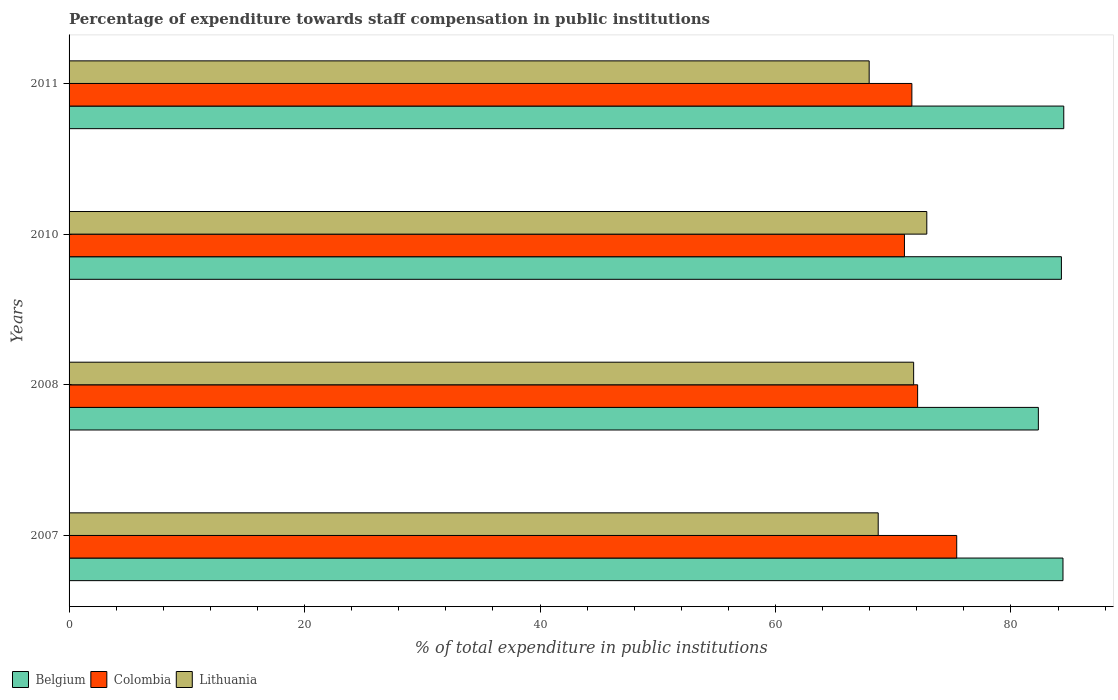How many different coloured bars are there?
Offer a very short reply. 3. Are the number of bars per tick equal to the number of legend labels?
Your answer should be very brief. Yes. Are the number of bars on each tick of the Y-axis equal?
Make the answer very short. Yes. How many bars are there on the 2nd tick from the top?
Your response must be concise. 3. How many bars are there on the 3rd tick from the bottom?
Your answer should be compact. 3. What is the label of the 2nd group of bars from the top?
Offer a very short reply. 2010. What is the percentage of expenditure towards staff compensation in Colombia in 2010?
Your response must be concise. 70.95. Across all years, what is the maximum percentage of expenditure towards staff compensation in Lithuania?
Give a very brief answer. 72.85. Across all years, what is the minimum percentage of expenditure towards staff compensation in Lithuania?
Give a very brief answer. 67.96. In which year was the percentage of expenditure towards staff compensation in Lithuania minimum?
Provide a succinct answer. 2011. What is the total percentage of expenditure towards staff compensation in Lithuania in the graph?
Your answer should be very brief. 281.26. What is the difference between the percentage of expenditure towards staff compensation in Lithuania in 2010 and that in 2011?
Keep it short and to the point. 4.89. What is the difference between the percentage of expenditure towards staff compensation in Colombia in 2008 and the percentage of expenditure towards staff compensation in Belgium in 2007?
Give a very brief answer. -12.35. What is the average percentage of expenditure towards staff compensation in Belgium per year?
Offer a very short reply. 83.88. In the year 2007, what is the difference between the percentage of expenditure towards staff compensation in Lithuania and percentage of expenditure towards staff compensation in Colombia?
Offer a terse response. -6.67. In how many years, is the percentage of expenditure towards staff compensation in Lithuania greater than 36 %?
Offer a very short reply. 4. What is the ratio of the percentage of expenditure towards staff compensation in Colombia in 2010 to that in 2011?
Provide a succinct answer. 0.99. Is the percentage of expenditure towards staff compensation in Lithuania in 2007 less than that in 2011?
Your answer should be very brief. No. Is the difference between the percentage of expenditure towards staff compensation in Lithuania in 2007 and 2011 greater than the difference between the percentage of expenditure towards staff compensation in Colombia in 2007 and 2011?
Provide a short and direct response. No. What is the difference between the highest and the second highest percentage of expenditure towards staff compensation in Belgium?
Offer a terse response. 0.07. What is the difference between the highest and the lowest percentage of expenditure towards staff compensation in Lithuania?
Make the answer very short. 4.89. What does the 3rd bar from the bottom in 2008 represents?
Your response must be concise. Lithuania. Are all the bars in the graph horizontal?
Your response must be concise. Yes. What is the difference between two consecutive major ticks on the X-axis?
Offer a very short reply. 20. Are the values on the major ticks of X-axis written in scientific E-notation?
Give a very brief answer. No. Does the graph contain grids?
Provide a succinct answer. No. Where does the legend appear in the graph?
Make the answer very short. Bottom left. How many legend labels are there?
Your response must be concise. 3. How are the legend labels stacked?
Your answer should be very brief. Horizontal. What is the title of the graph?
Make the answer very short. Percentage of expenditure towards staff compensation in public institutions. Does "Malta" appear as one of the legend labels in the graph?
Provide a succinct answer. No. What is the label or title of the X-axis?
Keep it short and to the point. % of total expenditure in public institutions. What is the label or title of the Y-axis?
Make the answer very short. Years. What is the % of total expenditure in public institutions in Belgium in 2007?
Your response must be concise. 84.42. What is the % of total expenditure in public institutions in Colombia in 2007?
Ensure brevity in your answer.  75.39. What is the % of total expenditure in public institutions of Lithuania in 2007?
Provide a short and direct response. 68.72. What is the % of total expenditure in public institutions of Belgium in 2008?
Your response must be concise. 82.33. What is the % of total expenditure in public institutions in Colombia in 2008?
Your response must be concise. 72.07. What is the % of total expenditure in public institutions of Lithuania in 2008?
Offer a terse response. 71.73. What is the % of total expenditure in public institutions in Belgium in 2010?
Make the answer very short. 84.28. What is the % of total expenditure in public institutions of Colombia in 2010?
Offer a very short reply. 70.95. What is the % of total expenditure in public institutions in Lithuania in 2010?
Your answer should be very brief. 72.85. What is the % of total expenditure in public institutions of Belgium in 2011?
Make the answer very short. 84.48. What is the % of total expenditure in public institutions in Colombia in 2011?
Offer a very short reply. 71.58. What is the % of total expenditure in public institutions in Lithuania in 2011?
Ensure brevity in your answer.  67.96. Across all years, what is the maximum % of total expenditure in public institutions of Belgium?
Ensure brevity in your answer.  84.48. Across all years, what is the maximum % of total expenditure in public institutions of Colombia?
Offer a terse response. 75.39. Across all years, what is the maximum % of total expenditure in public institutions of Lithuania?
Give a very brief answer. 72.85. Across all years, what is the minimum % of total expenditure in public institutions in Belgium?
Your answer should be compact. 82.33. Across all years, what is the minimum % of total expenditure in public institutions of Colombia?
Keep it short and to the point. 70.95. Across all years, what is the minimum % of total expenditure in public institutions in Lithuania?
Provide a short and direct response. 67.96. What is the total % of total expenditure in public institutions of Belgium in the graph?
Offer a terse response. 335.51. What is the total % of total expenditure in public institutions of Colombia in the graph?
Make the answer very short. 290. What is the total % of total expenditure in public institutions in Lithuania in the graph?
Offer a very short reply. 281.26. What is the difference between the % of total expenditure in public institutions in Belgium in 2007 and that in 2008?
Your response must be concise. 2.09. What is the difference between the % of total expenditure in public institutions of Colombia in 2007 and that in 2008?
Provide a short and direct response. 3.32. What is the difference between the % of total expenditure in public institutions in Lithuania in 2007 and that in 2008?
Make the answer very short. -3.01. What is the difference between the % of total expenditure in public institutions of Belgium in 2007 and that in 2010?
Offer a very short reply. 0.14. What is the difference between the % of total expenditure in public institutions of Colombia in 2007 and that in 2010?
Offer a very short reply. 4.44. What is the difference between the % of total expenditure in public institutions of Lithuania in 2007 and that in 2010?
Your answer should be very brief. -4.13. What is the difference between the % of total expenditure in public institutions of Belgium in 2007 and that in 2011?
Provide a short and direct response. -0.07. What is the difference between the % of total expenditure in public institutions in Colombia in 2007 and that in 2011?
Offer a very short reply. 3.81. What is the difference between the % of total expenditure in public institutions of Lithuania in 2007 and that in 2011?
Your response must be concise. 0.77. What is the difference between the % of total expenditure in public institutions of Belgium in 2008 and that in 2010?
Offer a very short reply. -1.96. What is the difference between the % of total expenditure in public institutions in Colombia in 2008 and that in 2010?
Your answer should be compact. 1.12. What is the difference between the % of total expenditure in public institutions in Lithuania in 2008 and that in 2010?
Your response must be concise. -1.12. What is the difference between the % of total expenditure in public institutions of Belgium in 2008 and that in 2011?
Offer a terse response. -2.16. What is the difference between the % of total expenditure in public institutions of Colombia in 2008 and that in 2011?
Your answer should be compact. 0.49. What is the difference between the % of total expenditure in public institutions in Lithuania in 2008 and that in 2011?
Keep it short and to the point. 3.78. What is the difference between the % of total expenditure in public institutions of Belgium in 2010 and that in 2011?
Give a very brief answer. -0.2. What is the difference between the % of total expenditure in public institutions in Colombia in 2010 and that in 2011?
Offer a terse response. -0.63. What is the difference between the % of total expenditure in public institutions in Lithuania in 2010 and that in 2011?
Provide a succinct answer. 4.89. What is the difference between the % of total expenditure in public institutions of Belgium in 2007 and the % of total expenditure in public institutions of Colombia in 2008?
Make the answer very short. 12.35. What is the difference between the % of total expenditure in public institutions in Belgium in 2007 and the % of total expenditure in public institutions in Lithuania in 2008?
Ensure brevity in your answer.  12.69. What is the difference between the % of total expenditure in public institutions of Colombia in 2007 and the % of total expenditure in public institutions of Lithuania in 2008?
Provide a short and direct response. 3.66. What is the difference between the % of total expenditure in public institutions of Belgium in 2007 and the % of total expenditure in public institutions of Colombia in 2010?
Make the answer very short. 13.47. What is the difference between the % of total expenditure in public institutions in Belgium in 2007 and the % of total expenditure in public institutions in Lithuania in 2010?
Provide a succinct answer. 11.57. What is the difference between the % of total expenditure in public institutions in Colombia in 2007 and the % of total expenditure in public institutions in Lithuania in 2010?
Offer a terse response. 2.54. What is the difference between the % of total expenditure in public institutions in Belgium in 2007 and the % of total expenditure in public institutions in Colombia in 2011?
Give a very brief answer. 12.84. What is the difference between the % of total expenditure in public institutions of Belgium in 2007 and the % of total expenditure in public institutions of Lithuania in 2011?
Offer a terse response. 16.46. What is the difference between the % of total expenditure in public institutions in Colombia in 2007 and the % of total expenditure in public institutions in Lithuania in 2011?
Provide a succinct answer. 7.44. What is the difference between the % of total expenditure in public institutions in Belgium in 2008 and the % of total expenditure in public institutions in Colombia in 2010?
Provide a succinct answer. 11.37. What is the difference between the % of total expenditure in public institutions in Belgium in 2008 and the % of total expenditure in public institutions in Lithuania in 2010?
Ensure brevity in your answer.  9.48. What is the difference between the % of total expenditure in public institutions in Colombia in 2008 and the % of total expenditure in public institutions in Lithuania in 2010?
Make the answer very short. -0.78. What is the difference between the % of total expenditure in public institutions of Belgium in 2008 and the % of total expenditure in public institutions of Colombia in 2011?
Your answer should be very brief. 10.74. What is the difference between the % of total expenditure in public institutions in Belgium in 2008 and the % of total expenditure in public institutions in Lithuania in 2011?
Offer a very short reply. 14.37. What is the difference between the % of total expenditure in public institutions of Colombia in 2008 and the % of total expenditure in public institutions of Lithuania in 2011?
Your answer should be very brief. 4.12. What is the difference between the % of total expenditure in public institutions in Belgium in 2010 and the % of total expenditure in public institutions in Colombia in 2011?
Ensure brevity in your answer.  12.7. What is the difference between the % of total expenditure in public institutions in Belgium in 2010 and the % of total expenditure in public institutions in Lithuania in 2011?
Offer a very short reply. 16.33. What is the difference between the % of total expenditure in public institutions in Colombia in 2010 and the % of total expenditure in public institutions in Lithuania in 2011?
Make the answer very short. 3. What is the average % of total expenditure in public institutions of Belgium per year?
Offer a terse response. 83.88. What is the average % of total expenditure in public institutions in Colombia per year?
Give a very brief answer. 72.5. What is the average % of total expenditure in public institutions in Lithuania per year?
Keep it short and to the point. 70.32. In the year 2007, what is the difference between the % of total expenditure in public institutions in Belgium and % of total expenditure in public institutions in Colombia?
Keep it short and to the point. 9.03. In the year 2007, what is the difference between the % of total expenditure in public institutions of Belgium and % of total expenditure in public institutions of Lithuania?
Give a very brief answer. 15.69. In the year 2007, what is the difference between the % of total expenditure in public institutions in Colombia and % of total expenditure in public institutions in Lithuania?
Keep it short and to the point. 6.67. In the year 2008, what is the difference between the % of total expenditure in public institutions in Belgium and % of total expenditure in public institutions in Colombia?
Keep it short and to the point. 10.25. In the year 2008, what is the difference between the % of total expenditure in public institutions in Belgium and % of total expenditure in public institutions in Lithuania?
Your response must be concise. 10.59. In the year 2008, what is the difference between the % of total expenditure in public institutions in Colombia and % of total expenditure in public institutions in Lithuania?
Make the answer very short. 0.34. In the year 2010, what is the difference between the % of total expenditure in public institutions in Belgium and % of total expenditure in public institutions in Colombia?
Provide a short and direct response. 13.33. In the year 2010, what is the difference between the % of total expenditure in public institutions of Belgium and % of total expenditure in public institutions of Lithuania?
Keep it short and to the point. 11.43. In the year 2010, what is the difference between the % of total expenditure in public institutions of Colombia and % of total expenditure in public institutions of Lithuania?
Offer a very short reply. -1.9. In the year 2011, what is the difference between the % of total expenditure in public institutions in Belgium and % of total expenditure in public institutions in Colombia?
Provide a short and direct response. 12.9. In the year 2011, what is the difference between the % of total expenditure in public institutions of Belgium and % of total expenditure in public institutions of Lithuania?
Offer a terse response. 16.53. In the year 2011, what is the difference between the % of total expenditure in public institutions in Colombia and % of total expenditure in public institutions in Lithuania?
Offer a very short reply. 3.63. What is the ratio of the % of total expenditure in public institutions in Belgium in 2007 to that in 2008?
Provide a succinct answer. 1.03. What is the ratio of the % of total expenditure in public institutions in Colombia in 2007 to that in 2008?
Your answer should be compact. 1.05. What is the ratio of the % of total expenditure in public institutions in Lithuania in 2007 to that in 2008?
Make the answer very short. 0.96. What is the ratio of the % of total expenditure in public institutions in Belgium in 2007 to that in 2010?
Provide a short and direct response. 1. What is the ratio of the % of total expenditure in public institutions in Colombia in 2007 to that in 2010?
Your answer should be compact. 1.06. What is the ratio of the % of total expenditure in public institutions of Lithuania in 2007 to that in 2010?
Your response must be concise. 0.94. What is the ratio of the % of total expenditure in public institutions in Belgium in 2007 to that in 2011?
Your response must be concise. 1. What is the ratio of the % of total expenditure in public institutions of Colombia in 2007 to that in 2011?
Your response must be concise. 1.05. What is the ratio of the % of total expenditure in public institutions of Lithuania in 2007 to that in 2011?
Your response must be concise. 1.01. What is the ratio of the % of total expenditure in public institutions in Belgium in 2008 to that in 2010?
Ensure brevity in your answer.  0.98. What is the ratio of the % of total expenditure in public institutions of Colombia in 2008 to that in 2010?
Keep it short and to the point. 1.02. What is the ratio of the % of total expenditure in public institutions of Lithuania in 2008 to that in 2010?
Your answer should be compact. 0.98. What is the ratio of the % of total expenditure in public institutions of Belgium in 2008 to that in 2011?
Make the answer very short. 0.97. What is the ratio of the % of total expenditure in public institutions of Colombia in 2008 to that in 2011?
Your answer should be very brief. 1.01. What is the ratio of the % of total expenditure in public institutions in Lithuania in 2008 to that in 2011?
Give a very brief answer. 1.06. What is the ratio of the % of total expenditure in public institutions of Colombia in 2010 to that in 2011?
Your response must be concise. 0.99. What is the ratio of the % of total expenditure in public institutions in Lithuania in 2010 to that in 2011?
Your response must be concise. 1.07. What is the difference between the highest and the second highest % of total expenditure in public institutions of Belgium?
Keep it short and to the point. 0.07. What is the difference between the highest and the second highest % of total expenditure in public institutions in Colombia?
Ensure brevity in your answer.  3.32. What is the difference between the highest and the second highest % of total expenditure in public institutions in Lithuania?
Provide a succinct answer. 1.12. What is the difference between the highest and the lowest % of total expenditure in public institutions of Belgium?
Offer a terse response. 2.16. What is the difference between the highest and the lowest % of total expenditure in public institutions of Colombia?
Offer a very short reply. 4.44. What is the difference between the highest and the lowest % of total expenditure in public institutions in Lithuania?
Your response must be concise. 4.89. 